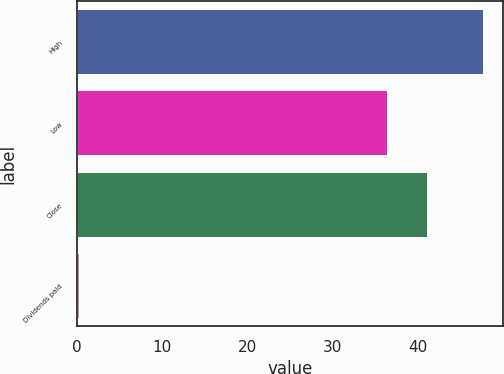<chart> <loc_0><loc_0><loc_500><loc_500><bar_chart><fcel>High<fcel>Low<fcel>Close<fcel>Dividends paid<nl><fcel>47.59<fcel>36.31<fcel>41.05<fcel>0.22<nl></chart> 